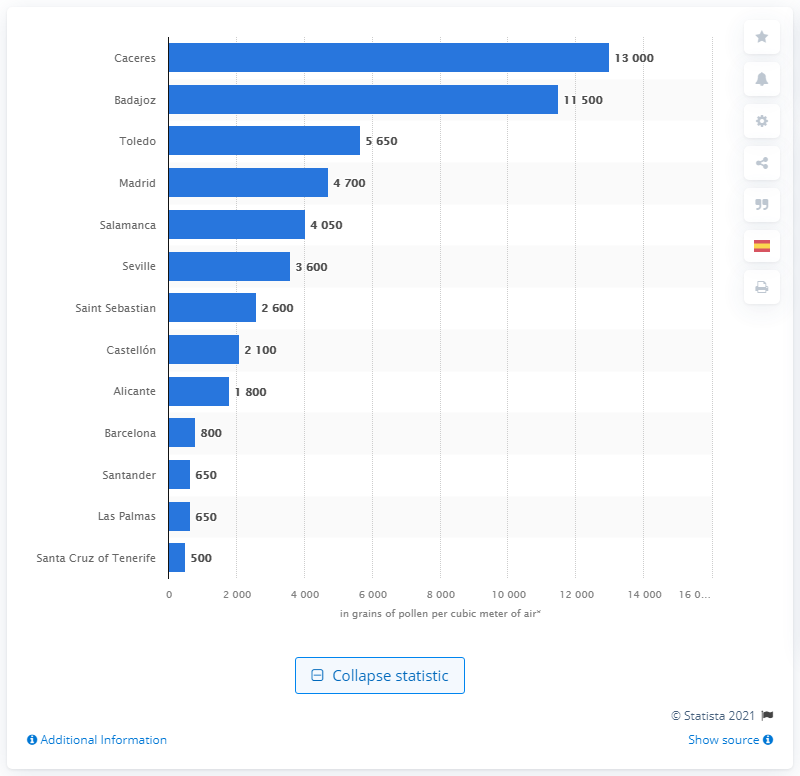List a handful of essential elements in this visual. In 2017, there were approximately 13,000 grains of pollen per cubic meter of air in Caceres. 